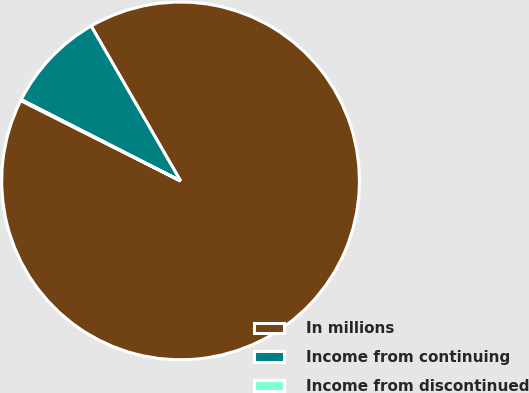<chart> <loc_0><loc_0><loc_500><loc_500><pie_chart><fcel>In millions<fcel>Income from continuing<fcel>Income from discontinued<nl><fcel>90.75%<fcel>9.16%<fcel>0.09%<nl></chart> 